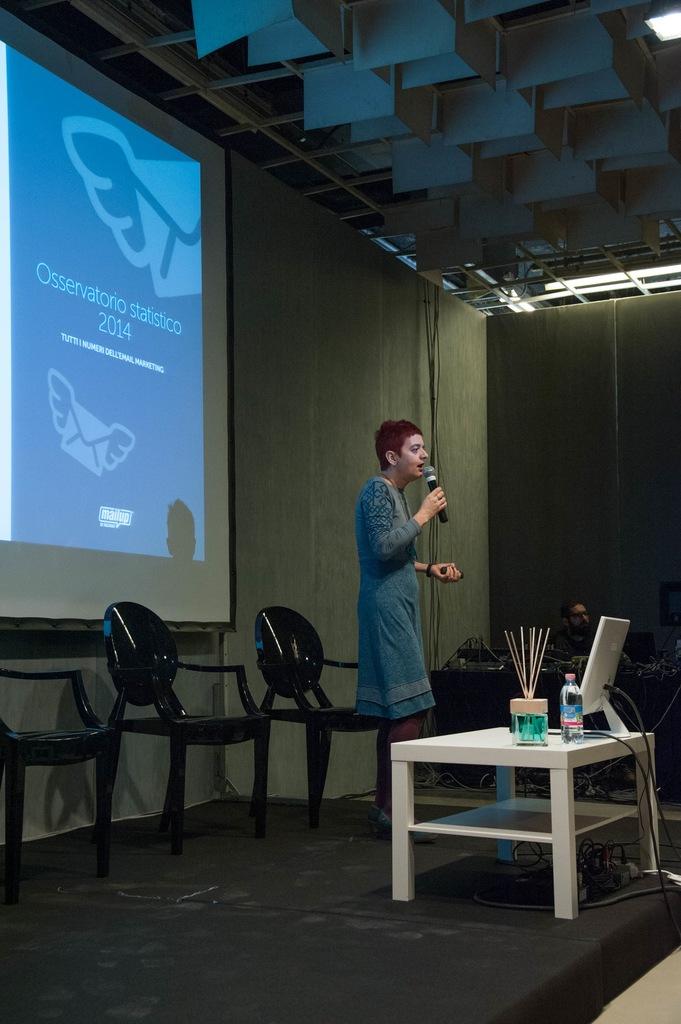The year on the blue screen is?
Provide a succinct answer. 2014. What is the presentation about?
Make the answer very short. Osservatorio statistico. 